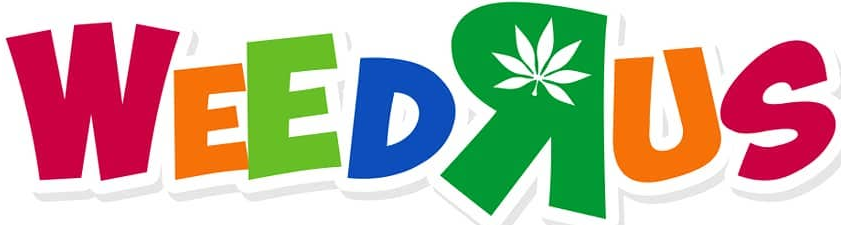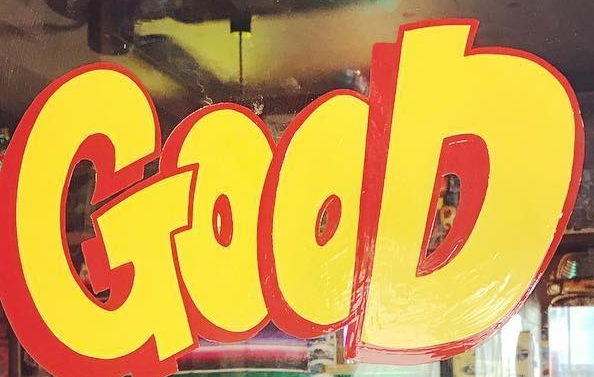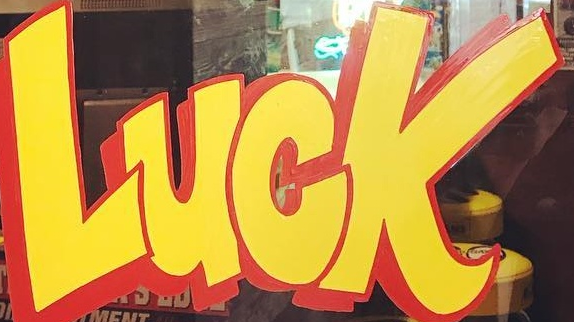What words are shown in these images in order, separated by a semicolon? WEEDRUS; GOOD; LUCK 